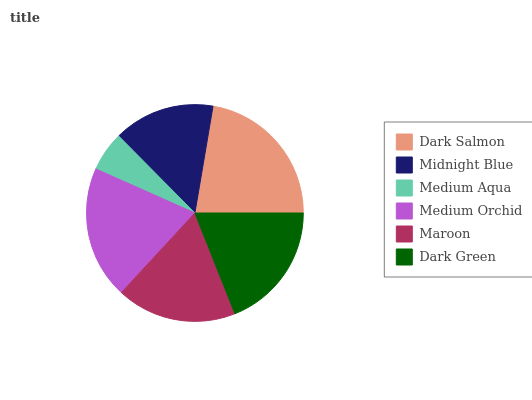Is Medium Aqua the minimum?
Answer yes or no. Yes. Is Dark Salmon the maximum?
Answer yes or no. Yes. Is Midnight Blue the minimum?
Answer yes or no. No. Is Midnight Blue the maximum?
Answer yes or no. No. Is Dark Salmon greater than Midnight Blue?
Answer yes or no. Yes. Is Midnight Blue less than Dark Salmon?
Answer yes or no. Yes. Is Midnight Blue greater than Dark Salmon?
Answer yes or no. No. Is Dark Salmon less than Midnight Blue?
Answer yes or no. No. Is Dark Green the high median?
Answer yes or no. Yes. Is Maroon the low median?
Answer yes or no. Yes. Is Dark Salmon the high median?
Answer yes or no. No. Is Medium Orchid the low median?
Answer yes or no. No. 